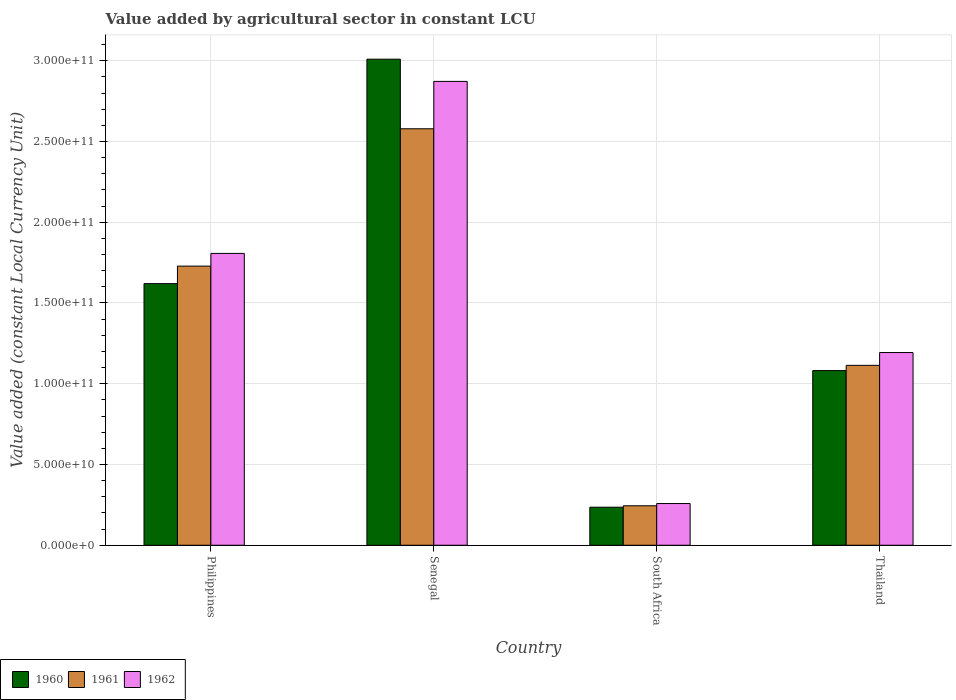Are the number of bars per tick equal to the number of legend labels?
Provide a succinct answer. Yes. Are the number of bars on each tick of the X-axis equal?
Keep it short and to the point. Yes. How many bars are there on the 2nd tick from the left?
Give a very brief answer. 3. How many bars are there on the 1st tick from the right?
Your answer should be compact. 3. In how many cases, is the number of bars for a given country not equal to the number of legend labels?
Provide a succinct answer. 0. What is the value added by agricultural sector in 1961 in South Africa?
Provide a short and direct response. 2.44e+1. Across all countries, what is the maximum value added by agricultural sector in 1960?
Provide a short and direct response. 3.01e+11. Across all countries, what is the minimum value added by agricultural sector in 1960?
Offer a terse response. 2.36e+1. In which country was the value added by agricultural sector in 1960 maximum?
Offer a terse response. Senegal. In which country was the value added by agricultural sector in 1962 minimum?
Provide a succinct answer. South Africa. What is the total value added by agricultural sector in 1962 in the graph?
Offer a very short reply. 6.13e+11. What is the difference between the value added by agricultural sector in 1961 in South Africa and that in Thailand?
Give a very brief answer. -8.70e+1. What is the difference between the value added by agricultural sector in 1961 in Thailand and the value added by agricultural sector in 1962 in Philippines?
Keep it short and to the point. -6.93e+1. What is the average value added by agricultural sector in 1961 per country?
Provide a short and direct response. 1.42e+11. What is the difference between the value added by agricultural sector of/in 1962 and value added by agricultural sector of/in 1961 in Thailand?
Make the answer very short. 7.93e+09. In how many countries, is the value added by agricultural sector in 1961 greater than 270000000000 LCU?
Provide a short and direct response. 0. What is the ratio of the value added by agricultural sector in 1961 in South Africa to that in Thailand?
Provide a short and direct response. 0.22. Is the difference between the value added by agricultural sector in 1962 in Philippines and Senegal greater than the difference between the value added by agricultural sector in 1961 in Philippines and Senegal?
Your answer should be very brief. No. What is the difference between the highest and the second highest value added by agricultural sector in 1960?
Give a very brief answer. -1.39e+11. What is the difference between the highest and the lowest value added by agricultural sector in 1961?
Provide a succinct answer. 2.33e+11. What does the 1st bar from the left in South Africa represents?
Keep it short and to the point. 1960. Is it the case that in every country, the sum of the value added by agricultural sector in 1961 and value added by agricultural sector in 1960 is greater than the value added by agricultural sector in 1962?
Give a very brief answer. Yes. How many bars are there?
Make the answer very short. 12. Are all the bars in the graph horizontal?
Offer a very short reply. No. How many legend labels are there?
Provide a short and direct response. 3. How are the legend labels stacked?
Offer a terse response. Horizontal. What is the title of the graph?
Your answer should be compact. Value added by agricultural sector in constant LCU. Does "1970" appear as one of the legend labels in the graph?
Your answer should be compact. No. What is the label or title of the X-axis?
Keep it short and to the point. Country. What is the label or title of the Y-axis?
Provide a succinct answer. Value added (constant Local Currency Unit). What is the Value added (constant Local Currency Unit) in 1960 in Philippines?
Offer a terse response. 1.62e+11. What is the Value added (constant Local Currency Unit) in 1961 in Philippines?
Offer a very short reply. 1.73e+11. What is the Value added (constant Local Currency Unit) of 1962 in Philippines?
Make the answer very short. 1.81e+11. What is the Value added (constant Local Currency Unit) of 1960 in Senegal?
Your response must be concise. 3.01e+11. What is the Value added (constant Local Currency Unit) in 1961 in Senegal?
Offer a very short reply. 2.58e+11. What is the Value added (constant Local Currency Unit) of 1962 in Senegal?
Your answer should be compact. 2.87e+11. What is the Value added (constant Local Currency Unit) in 1960 in South Africa?
Give a very brief answer. 2.36e+1. What is the Value added (constant Local Currency Unit) of 1961 in South Africa?
Give a very brief answer. 2.44e+1. What is the Value added (constant Local Currency Unit) of 1962 in South Africa?
Ensure brevity in your answer.  2.58e+1. What is the Value added (constant Local Currency Unit) in 1960 in Thailand?
Give a very brief answer. 1.08e+11. What is the Value added (constant Local Currency Unit) of 1961 in Thailand?
Ensure brevity in your answer.  1.11e+11. What is the Value added (constant Local Currency Unit) of 1962 in Thailand?
Offer a very short reply. 1.19e+11. Across all countries, what is the maximum Value added (constant Local Currency Unit) in 1960?
Your answer should be compact. 3.01e+11. Across all countries, what is the maximum Value added (constant Local Currency Unit) in 1961?
Your answer should be very brief. 2.58e+11. Across all countries, what is the maximum Value added (constant Local Currency Unit) of 1962?
Make the answer very short. 2.87e+11. Across all countries, what is the minimum Value added (constant Local Currency Unit) of 1960?
Your answer should be compact. 2.36e+1. Across all countries, what is the minimum Value added (constant Local Currency Unit) in 1961?
Keep it short and to the point. 2.44e+1. Across all countries, what is the minimum Value added (constant Local Currency Unit) in 1962?
Offer a terse response. 2.58e+1. What is the total Value added (constant Local Currency Unit) in 1960 in the graph?
Offer a very short reply. 5.95e+11. What is the total Value added (constant Local Currency Unit) in 1961 in the graph?
Your answer should be compact. 5.67e+11. What is the total Value added (constant Local Currency Unit) of 1962 in the graph?
Ensure brevity in your answer.  6.13e+11. What is the difference between the Value added (constant Local Currency Unit) of 1960 in Philippines and that in Senegal?
Provide a succinct answer. -1.39e+11. What is the difference between the Value added (constant Local Currency Unit) in 1961 in Philippines and that in Senegal?
Provide a short and direct response. -8.50e+1. What is the difference between the Value added (constant Local Currency Unit) in 1962 in Philippines and that in Senegal?
Give a very brief answer. -1.07e+11. What is the difference between the Value added (constant Local Currency Unit) of 1960 in Philippines and that in South Africa?
Your response must be concise. 1.38e+11. What is the difference between the Value added (constant Local Currency Unit) of 1961 in Philippines and that in South Africa?
Keep it short and to the point. 1.48e+11. What is the difference between the Value added (constant Local Currency Unit) in 1962 in Philippines and that in South Africa?
Your answer should be very brief. 1.55e+11. What is the difference between the Value added (constant Local Currency Unit) of 1960 in Philippines and that in Thailand?
Your answer should be very brief. 5.39e+1. What is the difference between the Value added (constant Local Currency Unit) in 1961 in Philippines and that in Thailand?
Your response must be concise. 6.14e+1. What is the difference between the Value added (constant Local Currency Unit) in 1962 in Philippines and that in Thailand?
Keep it short and to the point. 6.14e+1. What is the difference between the Value added (constant Local Currency Unit) in 1960 in Senegal and that in South Africa?
Provide a succinct answer. 2.77e+11. What is the difference between the Value added (constant Local Currency Unit) of 1961 in Senegal and that in South Africa?
Offer a very short reply. 2.33e+11. What is the difference between the Value added (constant Local Currency Unit) of 1962 in Senegal and that in South Africa?
Provide a succinct answer. 2.61e+11. What is the difference between the Value added (constant Local Currency Unit) of 1960 in Senegal and that in Thailand?
Ensure brevity in your answer.  1.93e+11. What is the difference between the Value added (constant Local Currency Unit) of 1961 in Senegal and that in Thailand?
Your answer should be compact. 1.46e+11. What is the difference between the Value added (constant Local Currency Unit) in 1962 in Senegal and that in Thailand?
Provide a short and direct response. 1.68e+11. What is the difference between the Value added (constant Local Currency Unit) in 1960 in South Africa and that in Thailand?
Give a very brief answer. -8.46e+1. What is the difference between the Value added (constant Local Currency Unit) of 1961 in South Africa and that in Thailand?
Offer a terse response. -8.70e+1. What is the difference between the Value added (constant Local Currency Unit) of 1962 in South Africa and that in Thailand?
Your answer should be compact. -9.35e+1. What is the difference between the Value added (constant Local Currency Unit) of 1960 in Philippines and the Value added (constant Local Currency Unit) of 1961 in Senegal?
Give a very brief answer. -9.59e+1. What is the difference between the Value added (constant Local Currency Unit) of 1960 in Philippines and the Value added (constant Local Currency Unit) of 1962 in Senegal?
Your response must be concise. -1.25e+11. What is the difference between the Value added (constant Local Currency Unit) of 1961 in Philippines and the Value added (constant Local Currency Unit) of 1962 in Senegal?
Your answer should be very brief. -1.14e+11. What is the difference between the Value added (constant Local Currency Unit) of 1960 in Philippines and the Value added (constant Local Currency Unit) of 1961 in South Africa?
Give a very brief answer. 1.38e+11. What is the difference between the Value added (constant Local Currency Unit) of 1960 in Philippines and the Value added (constant Local Currency Unit) of 1962 in South Africa?
Provide a succinct answer. 1.36e+11. What is the difference between the Value added (constant Local Currency Unit) in 1961 in Philippines and the Value added (constant Local Currency Unit) in 1962 in South Africa?
Your response must be concise. 1.47e+11. What is the difference between the Value added (constant Local Currency Unit) in 1960 in Philippines and the Value added (constant Local Currency Unit) in 1961 in Thailand?
Make the answer very short. 5.06e+1. What is the difference between the Value added (constant Local Currency Unit) of 1960 in Philippines and the Value added (constant Local Currency Unit) of 1962 in Thailand?
Your answer should be very brief. 4.27e+1. What is the difference between the Value added (constant Local Currency Unit) in 1961 in Philippines and the Value added (constant Local Currency Unit) in 1962 in Thailand?
Offer a very short reply. 5.35e+1. What is the difference between the Value added (constant Local Currency Unit) of 1960 in Senegal and the Value added (constant Local Currency Unit) of 1961 in South Africa?
Offer a very short reply. 2.77e+11. What is the difference between the Value added (constant Local Currency Unit) in 1960 in Senegal and the Value added (constant Local Currency Unit) in 1962 in South Africa?
Offer a terse response. 2.75e+11. What is the difference between the Value added (constant Local Currency Unit) in 1961 in Senegal and the Value added (constant Local Currency Unit) in 1962 in South Africa?
Offer a very short reply. 2.32e+11. What is the difference between the Value added (constant Local Currency Unit) of 1960 in Senegal and the Value added (constant Local Currency Unit) of 1961 in Thailand?
Keep it short and to the point. 1.90e+11. What is the difference between the Value added (constant Local Currency Unit) of 1960 in Senegal and the Value added (constant Local Currency Unit) of 1962 in Thailand?
Keep it short and to the point. 1.82e+11. What is the difference between the Value added (constant Local Currency Unit) of 1961 in Senegal and the Value added (constant Local Currency Unit) of 1962 in Thailand?
Offer a very short reply. 1.39e+11. What is the difference between the Value added (constant Local Currency Unit) of 1960 in South Africa and the Value added (constant Local Currency Unit) of 1961 in Thailand?
Your answer should be very brief. -8.78e+1. What is the difference between the Value added (constant Local Currency Unit) of 1960 in South Africa and the Value added (constant Local Currency Unit) of 1962 in Thailand?
Make the answer very short. -9.58e+1. What is the difference between the Value added (constant Local Currency Unit) in 1961 in South Africa and the Value added (constant Local Currency Unit) in 1962 in Thailand?
Your response must be concise. -9.49e+1. What is the average Value added (constant Local Currency Unit) of 1960 per country?
Your answer should be compact. 1.49e+11. What is the average Value added (constant Local Currency Unit) in 1961 per country?
Offer a very short reply. 1.42e+11. What is the average Value added (constant Local Currency Unit) in 1962 per country?
Make the answer very short. 1.53e+11. What is the difference between the Value added (constant Local Currency Unit) of 1960 and Value added (constant Local Currency Unit) of 1961 in Philippines?
Offer a very short reply. -1.08e+1. What is the difference between the Value added (constant Local Currency Unit) in 1960 and Value added (constant Local Currency Unit) in 1962 in Philippines?
Your answer should be compact. -1.87e+1. What is the difference between the Value added (constant Local Currency Unit) of 1961 and Value added (constant Local Currency Unit) of 1962 in Philippines?
Provide a succinct answer. -7.86e+09. What is the difference between the Value added (constant Local Currency Unit) of 1960 and Value added (constant Local Currency Unit) of 1961 in Senegal?
Offer a very short reply. 4.31e+1. What is the difference between the Value added (constant Local Currency Unit) in 1960 and Value added (constant Local Currency Unit) in 1962 in Senegal?
Keep it short and to the point. 1.38e+1. What is the difference between the Value added (constant Local Currency Unit) in 1961 and Value added (constant Local Currency Unit) in 1962 in Senegal?
Your answer should be very brief. -2.93e+1. What is the difference between the Value added (constant Local Currency Unit) in 1960 and Value added (constant Local Currency Unit) in 1961 in South Africa?
Your answer should be compact. -8.75e+08. What is the difference between the Value added (constant Local Currency Unit) of 1960 and Value added (constant Local Currency Unit) of 1962 in South Africa?
Make the answer very short. -2.26e+09. What is the difference between the Value added (constant Local Currency Unit) of 1961 and Value added (constant Local Currency Unit) of 1962 in South Africa?
Your answer should be compact. -1.39e+09. What is the difference between the Value added (constant Local Currency Unit) of 1960 and Value added (constant Local Currency Unit) of 1961 in Thailand?
Provide a short and direct response. -3.26e+09. What is the difference between the Value added (constant Local Currency Unit) in 1960 and Value added (constant Local Currency Unit) in 1962 in Thailand?
Your response must be concise. -1.12e+1. What is the difference between the Value added (constant Local Currency Unit) in 1961 and Value added (constant Local Currency Unit) in 1962 in Thailand?
Give a very brief answer. -7.93e+09. What is the ratio of the Value added (constant Local Currency Unit) of 1960 in Philippines to that in Senegal?
Give a very brief answer. 0.54. What is the ratio of the Value added (constant Local Currency Unit) of 1961 in Philippines to that in Senegal?
Your response must be concise. 0.67. What is the ratio of the Value added (constant Local Currency Unit) of 1962 in Philippines to that in Senegal?
Offer a terse response. 0.63. What is the ratio of the Value added (constant Local Currency Unit) in 1960 in Philippines to that in South Africa?
Your answer should be very brief. 6.88. What is the ratio of the Value added (constant Local Currency Unit) of 1961 in Philippines to that in South Africa?
Provide a succinct answer. 7.07. What is the ratio of the Value added (constant Local Currency Unit) in 1962 in Philippines to that in South Africa?
Keep it short and to the point. 7. What is the ratio of the Value added (constant Local Currency Unit) of 1960 in Philippines to that in Thailand?
Ensure brevity in your answer.  1.5. What is the ratio of the Value added (constant Local Currency Unit) in 1961 in Philippines to that in Thailand?
Your answer should be very brief. 1.55. What is the ratio of the Value added (constant Local Currency Unit) in 1962 in Philippines to that in Thailand?
Your response must be concise. 1.51. What is the ratio of the Value added (constant Local Currency Unit) of 1960 in Senegal to that in South Africa?
Provide a succinct answer. 12.77. What is the ratio of the Value added (constant Local Currency Unit) in 1961 in Senegal to that in South Africa?
Your response must be concise. 10.55. What is the ratio of the Value added (constant Local Currency Unit) in 1962 in Senegal to that in South Africa?
Keep it short and to the point. 11.12. What is the ratio of the Value added (constant Local Currency Unit) of 1960 in Senegal to that in Thailand?
Your answer should be very brief. 2.78. What is the ratio of the Value added (constant Local Currency Unit) of 1961 in Senegal to that in Thailand?
Provide a short and direct response. 2.31. What is the ratio of the Value added (constant Local Currency Unit) of 1962 in Senegal to that in Thailand?
Provide a succinct answer. 2.41. What is the ratio of the Value added (constant Local Currency Unit) of 1960 in South Africa to that in Thailand?
Offer a very short reply. 0.22. What is the ratio of the Value added (constant Local Currency Unit) of 1961 in South Africa to that in Thailand?
Keep it short and to the point. 0.22. What is the ratio of the Value added (constant Local Currency Unit) in 1962 in South Africa to that in Thailand?
Keep it short and to the point. 0.22. What is the difference between the highest and the second highest Value added (constant Local Currency Unit) in 1960?
Offer a terse response. 1.39e+11. What is the difference between the highest and the second highest Value added (constant Local Currency Unit) in 1961?
Offer a terse response. 8.50e+1. What is the difference between the highest and the second highest Value added (constant Local Currency Unit) of 1962?
Make the answer very short. 1.07e+11. What is the difference between the highest and the lowest Value added (constant Local Currency Unit) in 1960?
Your answer should be compact. 2.77e+11. What is the difference between the highest and the lowest Value added (constant Local Currency Unit) in 1961?
Your response must be concise. 2.33e+11. What is the difference between the highest and the lowest Value added (constant Local Currency Unit) of 1962?
Your answer should be very brief. 2.61e+11. 